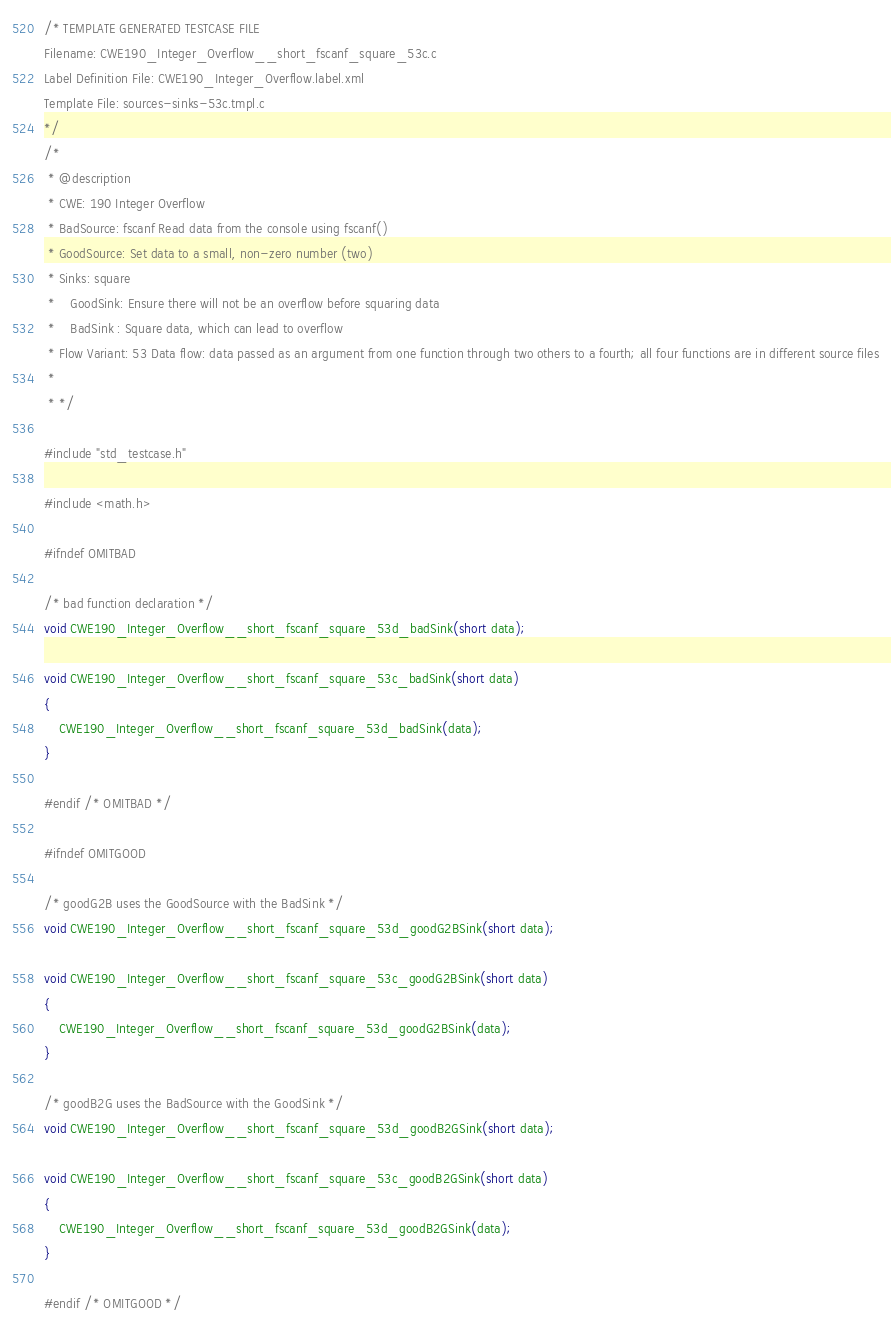<code> <loc_0><loc_0><loc_500><loc_500><_C_>/* TEMPLATE GENERATED TESTCASE FILE
Filename: CWE190_Integer_Overflow__short_fscanf_square_53c.c
Label Definition File: CWE190_Integer_Overflow.label.xml
Template File: sources-sinks-53c.tmpl.c
*/
/*
 * @description
 * CWE: 190 Integer Overflow
 * BadSource: fscanf Read data from the console using fscanf()
 * GoodSource: Set data to a small, non-zero number (two)
 * Sinks: square
 *    GoodSink: Ensure there will not be an overflow before squaring data
 *    BadSink : Square data, which can lead to overflow
 * Flow Variant: 53 Data flow: data passed as an argument from one function through two others to a fourth; all four functions are in different source files
 *
 * */

#include "std_testcase.h"

#include <math.h>

#ifndef OMITBAD

/* bad function declaration */
void CWE190_Integer_Overflow__short_fscanf_square_53d_badSink(short data);

void CWE190_Integer_Overflow__short_fscanf_square_53c_badSink(short data)
{
    CWE190_Integer_Overflow__short_fscanf_square_53d_badSink(data);
}

#endif /* OMITBAD */

#ifndef OMITGOOD

/* goodG2B uses the GoodSource with the BadSink */
void CWE190_Integer_Overflow__short_fscanf_square_53d_goodG2BSink(short data);

void CWE190_Integer_Overflow__short_fscanf_square_53c_goodG2BSink(short data)
{
    CWE190_Integer_Overflow__short_fscanf_square_53d_goodG2BSink(data);
}

/* goodB2G uses the BadSource with the GoodSink */
void CWE190_Integer_Overflow__short_fscanf_square_53d_goodB2GSink(short data);

void CWE190_Integer_Overflow__short_fscanf_square_53c_goodB2GSink(short data)
{
    CWE190_Integer_Overflow__short_fscanf_square_53d_goodB2GSink(data);
}

#endif /* OMITGOOD */
</code> 